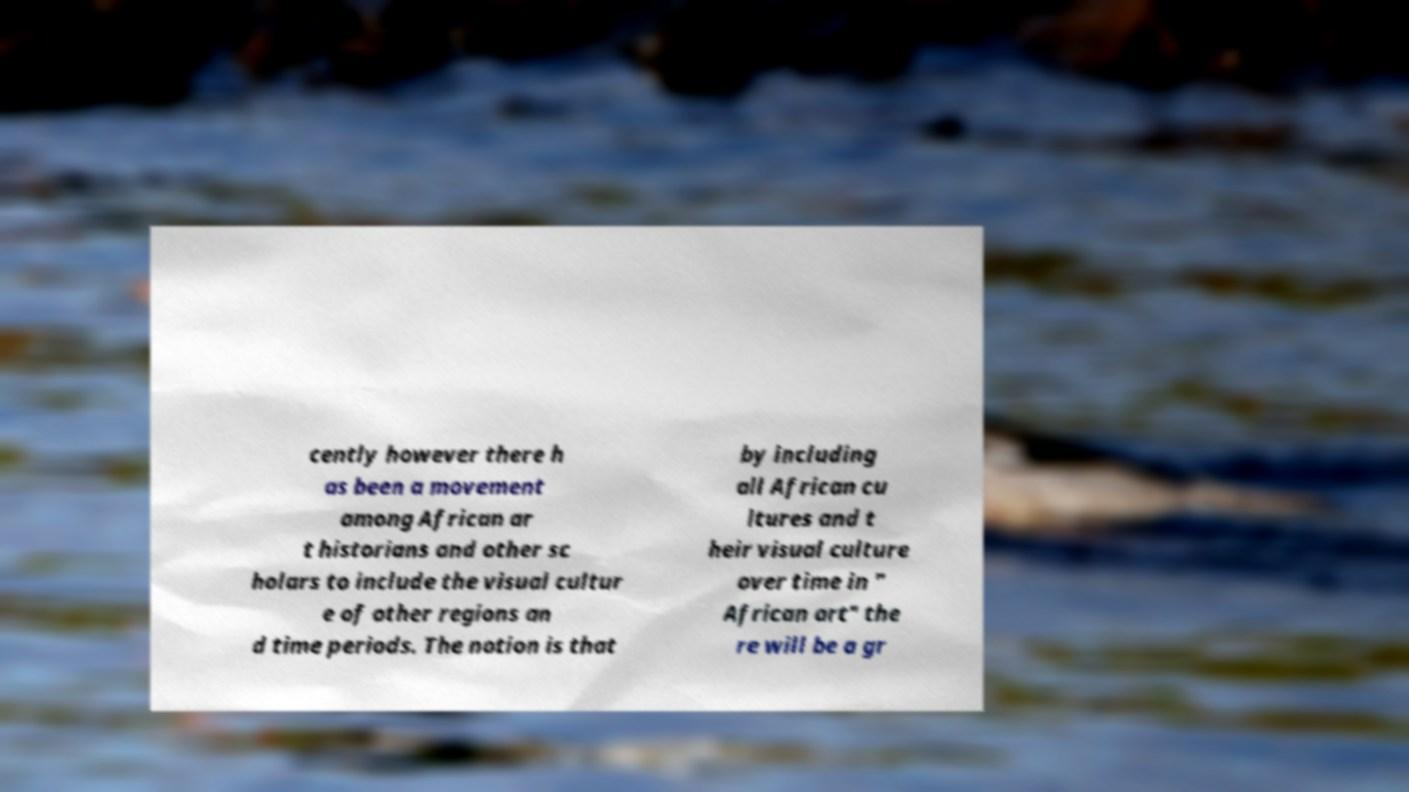There's text embedded in this image that I need extracted. Can you transcribe it verbatim? cently however there h as been a movement among African ar t historians and other sc holars to include the visual cultur e of other regions an d time periods. The notion is that by including all African cu ltures and t heir visual culture over time in " African art" the re will be a gr 